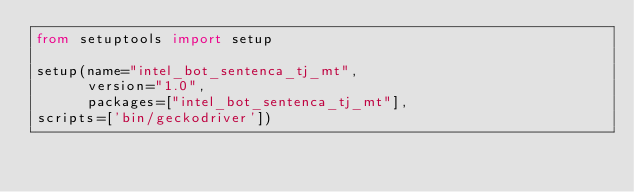<code> <loc_0><loc_0><loc_500><loc_500><_Python_>from setuptools import setup

setup(name="intel_bot_sentenca_tj_mt",
      version="1.0",
      packages=["intel_bot_sentenca_tj_mt"],
scripts=['bin/geckodriver'])
</code> 